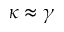Convert formula to latex. <formula><loc_0><loc_0><loc_500><loc_500>\kappa \approx \gamma</formula> 